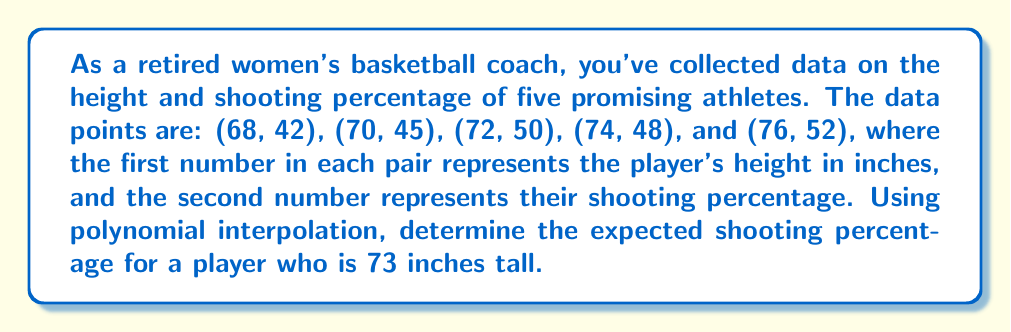Teach me how to tackle this problem. To solve this problem, we'll use Lagrange polynomial interpolation. The steps are as follows:

1) The Lagrange interpolation polynomial is given by:

   $$P(x) = \sum_{i=1}^n y_i \cdot L_i(x)$$

   where $L_i(x)$ is the Lagrange basis polynomial:

   $$L_i(x) = \prod_{j=1, j \neq i}^n \frac{x - x_j}{x_i - x_j}$$

2) We have 5 data points, so $n = 5$. Let's calculate each $L_i(73)$:

   $$L_1(73) = \frac{(73-70)(73-72)(73-74)(73-76)}{(68-70)(68-72)(68-74)(68-76)} = -0.0104$$
   $$L_2(73) = \frac{(73-68)(73-72)(73-74)(73-76)}{(70-68)(70-72)(70-74)(70-76)} = 0.0938$$
   $$L_3(73) = \frac{(73-68)(73-70)(73-74)(73-76)}{(72-68)(72-70)(72-74)(72-76)} = 0.9375$$
   $$L_4(73) = \frac{(73-68)(73-70)(73-72)(73-76)}{(74-68)(74-70)(74-72)(74-76)} = -0.0938$$
   $$L_5(73) = \frac{(73-68)(73-70)(73-72)(73-74)}{(76-68)(76-70)(76-72)(76-74)} = 0.0104$$

3) Now, we can calculate $P(73)$:

   $$P(73) = 42 \cdot (-0.0104) + 45 \cdot 0.0938 + 50 \cdot 0.9375 + 48 \cdot (-0.0938) + 52 \cdot 0.0104$$

4) Simplifying:

   $$P(73) = -0.4368 + 4.221 + 46.875 - 4.5024 + 0.5408 = 49.7076$$

5) Rounding to the nearest whole percentage:

   $$P(73) \approx 50\%$$
Answer: 50% 